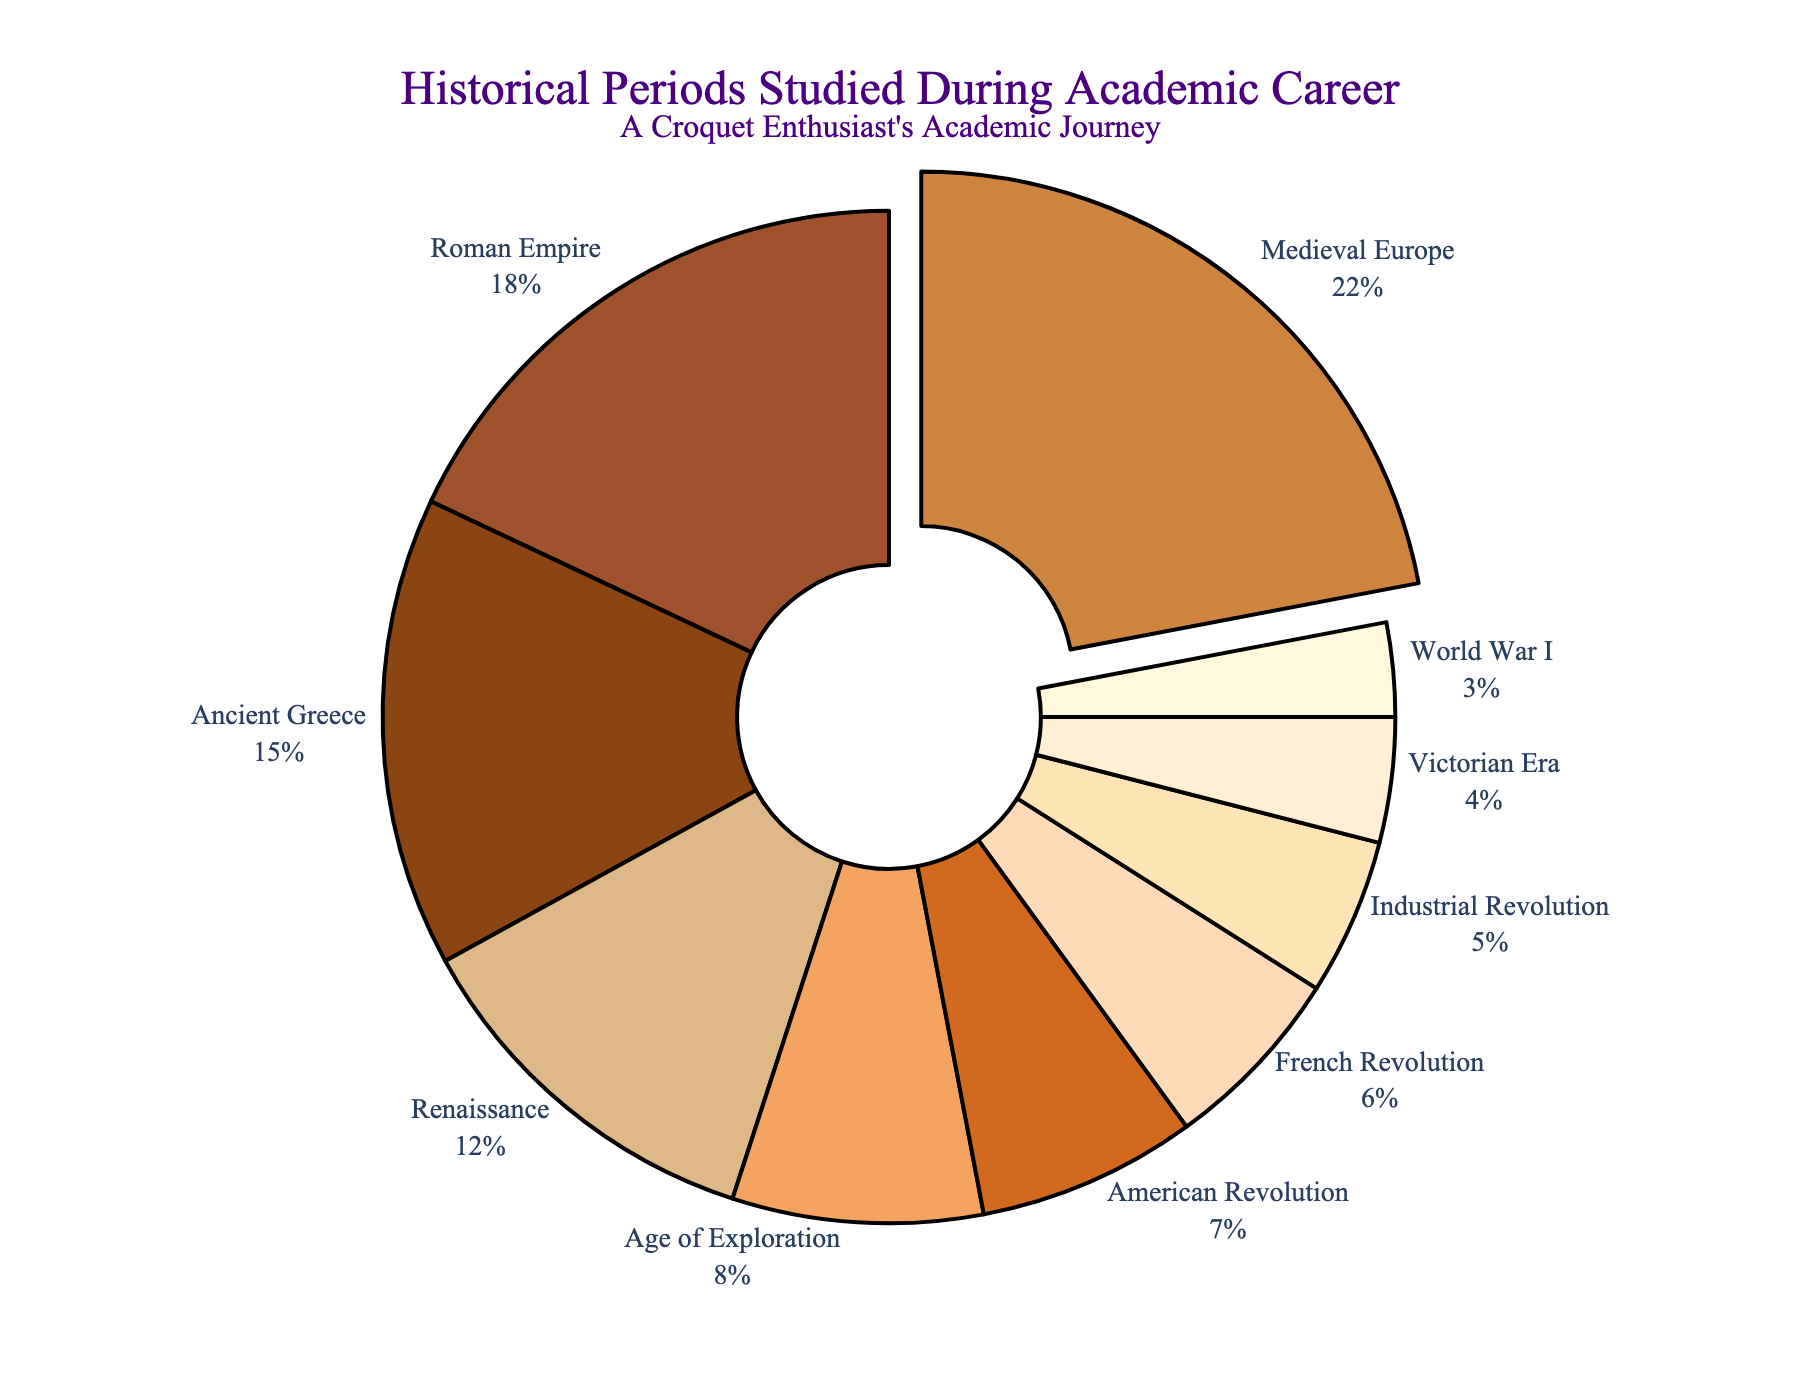What's the largest historical period studied during the academic career? The pie chart shows that Medieval Europe has the largest segment with 22%.
Answer: Medieval Europe Which historical period has the smallest percentage of study? The pie chart shows that World War I has the smallest segment with 3%.
Answer: World War I Between the Roman Empire and Ancient Greece, which period was studied more and by how much? Roman Empire (18%) is studied more than Ancient Greece (15%). The difference is 18% - 15% = 3%.
Answer: Roman Empire by 3% What is the combined percentage of studying the French Revolution and the American Revolution? The chart shows that the French Revolution is 6% and the American Revolution is 7%. Adding them: 6% + 7% = 13%.
Answer: 13% Which historical period is represented by a darker brown color? Medieval Europe is represented by a darker brown color and has the largest percentage of 22%.
Answer: Medieval Europe How much more was the Renaissance studied compared to the Industrial Revolution? The Renaissance is 12% and the Industrial Revolution is 5%. The difference is 12% - 5% = 7%.
Answer: 7% What percentage of study was dedicated to periods before the year 1000 AD (Ancient Greece, Roman Empire, Medieval Europe)? Ancient Greece (15%), Roman Empire (18%), and Medieval Europe (22%) combined: 15% + 18% + 22% = 55%.
Answer: 55% What is the joint percentage of the Victorian Era and World War I studies? Victorian Era is 4% and World War I is 3%. Adding them: 4% + 3% = 7%.
Answer: 7% Which period studied is represented by the lightest color on the chart? The Victorian Era is represented by the lightest color and has a percentage of 4%.
Answer: Victorian Era How many periods have a study percentage that is less than the Age of Exploration's percentage? The Age of Exploration has 8%. The periods less than this are American Revolution (7%), French Revolution (6%), Industrial Revolution (5%), Victorian Era (4%), and World War I (3%), totaling 5 periods.
Answer: 5 